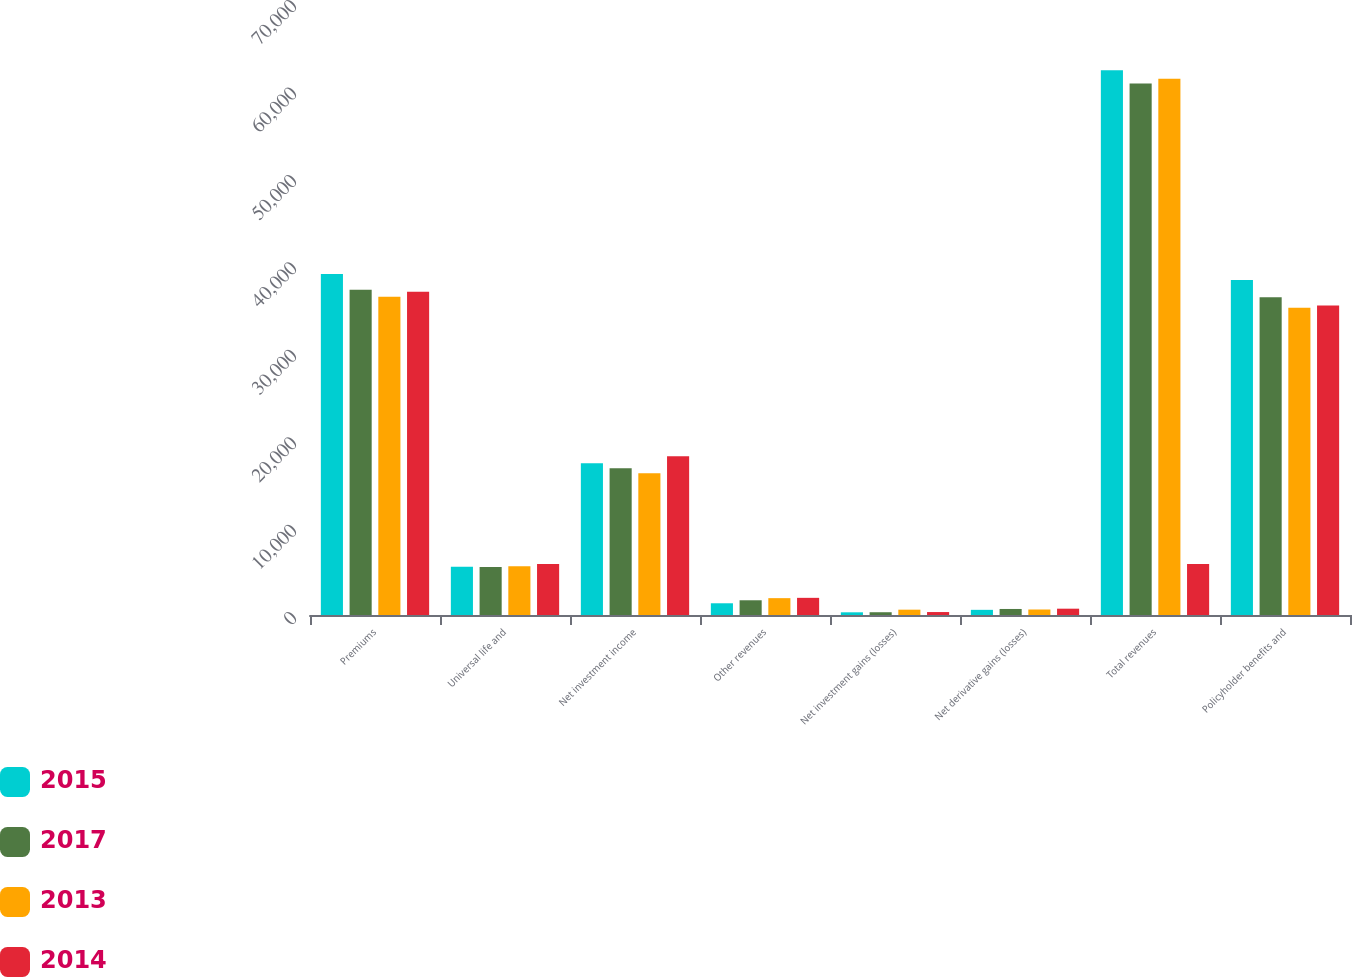<chart> <loc_0><loc_0><loc_500><loc_500><stacked_bar_chart><ecel><fcel>Premiums<fcel>Universal life and<fcel>Net investment income<fcel>Other revenues<fcel>Net investment gains (losses)<fcel>Net derivative gains (losses)<fcel>Total revenues<fcel>Policyholder benefits and<nl><fcel>2015<fcel>38992<fcel>5510<fcel>17363<fcel>1341<fcel>308<fcel>590<fcel>62308<fcel>38313<nl><fcel>2017<fcel>37202<fcel>5483<fcel>16790<fcel>1685<fcel>317<fcel>690<fcel>60787<fcel>36358<nl><fcel>2013<fcel>36403<fcel>5570<fcel>16205<fcel>1927<fcel>609<fcel>629<fcel>61343<fcel>35144<nl><fcel>2014<fcel>36970<fcel>5824<fcel>18158<fcel>1962<fcel>338<fcel>722<fcel>5824<fcel>35393<nl></chart> 